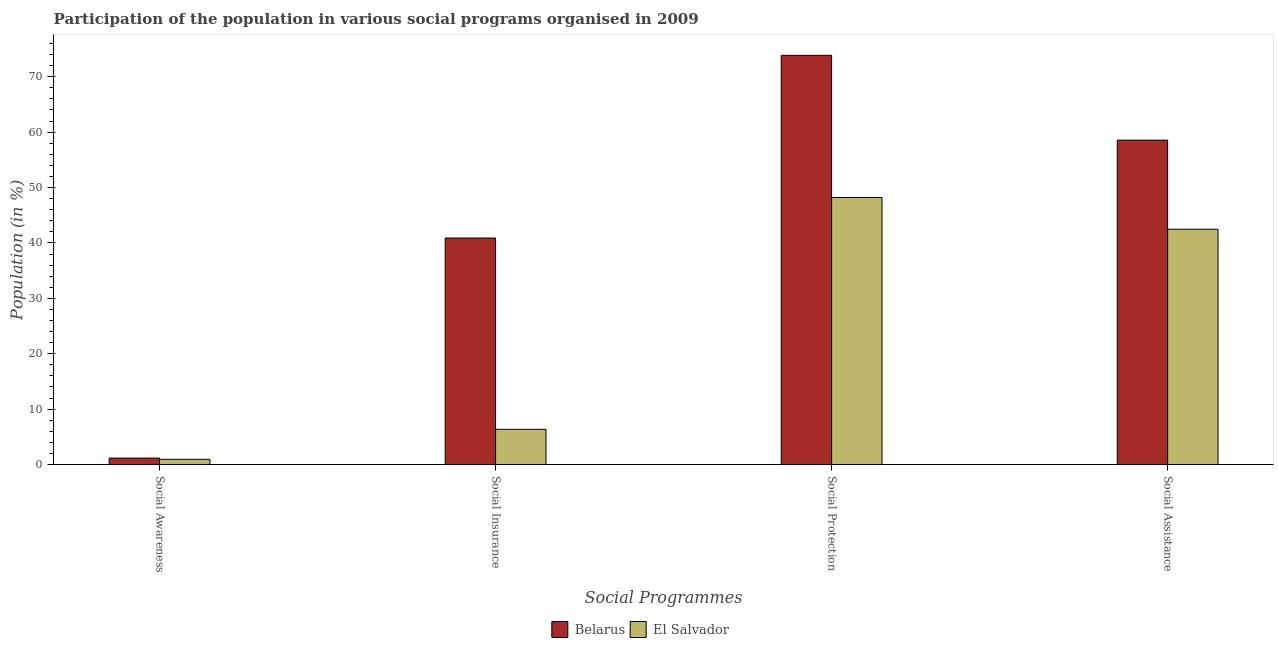Are the number of bars per tick equal to the number of legend labels?
Ensure brevity in your answer.  Yes. Are the number of bars on each tick of the X-axis equal?
Offer a very short reply. Yes. What is the label of the 4th group of bars from the left?
Give a very brief answer. Social Assistance. What is the participation of population in social assistance programs in El Salvador?
Your answer should be very brief. 42.48. Across all countries, what is the maximum participation of population in social assistance programs?
Ensure brevity in your answer.  58.55. Across all countries, what is the minimum participation of population in social awareness programs?
Your response must be concise. 0.95. In which country was the participation of population in social awareness programs maximum?
Offer a terse response. Belarus. In which country was the participation of population in social assistance programs minimum?
Keep it short and to the point. El Salvador. What is the total participation of population in social protection programs in the graph?
Ensure brevity in your answer.  122.06. What is the difference between the participation of population in social protection programs in Belarus and that in El Salvador?
Your response must be concise. 25.66. What is the difference between the participation of population in social awareness programs in Belarus and the participation of population in social insurance programs in El Salvador?
Give a very brief answer. -5.19. What is the average participation of population in social insurance programs per country?
Provide a short and direct response. 23.62. What is the difference between the participation of population in social insurance programs and participation of population in social protection programs in El Salvador?
Offer a very short reply. -41.84. What is the ratio of the participation of population in social awareness programs in Belarus to that in El Salvador?
Provide a short and direct response. 1.23. What is the difference between the highest and the second highest participation of population in social protection programs?
Make the answer very short. 25.66. What is the difference between the highest and the lowest participation of population in social assistance programs?
Keep it short and to the point. 16.07. In how many countries, is the participation of population in social assistance programs greater than the average participation of population in social assistance programs taken over all countries?
Offer a very short reply. 1. Is the sum of the participation of population in social assistance programs in Belarus and El Salvador greater than the maximum participation of population in social insurance programs across all countries?
Offer a terse response. Yes. Is it the case that in every country, the sum of the participation of population in social protection programs and participation of population in social assistance programs is greater than the sum of participation of population in social awareness programs and participation of population in social insurance programs?
Keep it short and to the point. Yes. What does the 2nd bar from the left in Social Insurance represents?
Keep it short and to the point. El Salvador. What does the 2nd bar from the right in Social Assistance represents?
Provide a succinct answer. Belarus. Is it the case that in every country, the sum of the participation of population in social awareness programs and participation of population in social insurance programs is greater than the participation of population in social protection programs?
Your answer should be very brief. No. Are all the bars in the graph horizontal?
Ensure brevity in your answer.  No. Are the values on the major ticks of Y-axis written in scientific E-notation?
Provide a short and direct response. No. Does the graph contain any zero values?
Make the answer very short. No. Where does the legend appear in the graph?
Offer a very short reply. Bottom center. How many legend labels are there?
Ensure brevity in your answer.  2. What is the title of the graph?
Give a very brief answer. Participation of the population in various social programs organised in 2009. What is the label or title of the X-axis?
Your answer should be compact. Social Programmes. What is the Population (in %) of Belarus in Social Awareness?
Your answer should be compact. 1.17. What is the Population (in %) in El Salvador in Social Awareness?
Provide a short and direct response. 0.95. What is the Population (in %) of Belarus in Social Insurance?
Offer a very short reply. 40.89. What is the Population (in %) in El Salvador in Social Insurance?
Offer a very short reply. 6.36. What is the Population (in %) in Belarus in Social Protection?
Offer a very short reply. 73.86. What is the Population (in %) in El Salvador in Social Protection?
Offer a very short reply. 48.2. What is the Population (in %) of Belarus in Social Assistance?
Your answer should be very brief. 58.55. What is the Population (in %) of El Salvador in Social Assistance?
Provide a short and direct response. 42.48. Across all Social Programmes, what is the maximum Population (in %) in Belarus?
Give a very brief answer. 73.86. Across all Social Programmes, what is the maximum Population (in %) in El Salvador?
Your response must be concise. 48.2. Across all Social Programmes, what is the minimum Population (in %) in Belarus?
Provide a succinct answer. 1.17. Across all Social Programmes, what is the minimum Population (in %) of El Salvador?
Offer a terse response. 0.95. What is the total Population (in %) of Belarus in the graph?
Your response must be concise. 174.46. What is the total Population (in %) in El Salvador in the graph?
Provide a succinct answer. 97.98. What is the difference between the Population (in %) in Belarus in Social Awareness and that in Social Insurance?
Provide a succinct answer. -39.72. What is the difference between the Population (in %) in El Salvador in Social Awareness and that in Social Insurance?
Provide a succinct answer. -5.41. What is the difference between the Population (in %) in Belarus in Social Awareness and that in Social Protection?
Ensure brevity in your answer.  -72.7. What is the difference between the Population (in %) in El Salvador in Social Awareness and that in Social Protection?
Keep it short and to the point. -47.26. What is the difference between the Population (in %) in Belarus in Social Awareness and that in Social Assistance?
Provide a short and direct response. -57.39. What is the difference between the Population (in %) in El Salvador in Social Awareness and that in Social Assistance?
Provide a succinct answer. -41.53. What is the difference between the Population (in %) in Belarus in Social Insurance and that in Social Protection?
Your answer should be compact. -32.98. What is the difference between the Population (in %) in El Salvador in Social Insurance and that in Social Protection?
Provide a succinct answer. -41.84. What is the difference between the Population (in %) in Belarus in Social Insurance and that in Social Assistance?
Provide a succinct answer. -17.67. What is the difference between the Population (in %) of El Salvador in Social Insurance and that in Social Assistance?
Your answer should be very brief. -36.12. What is the difference between the Population (in %) of Belarus in Social Protection and that in Social Assistance?
Give a very brief answer. 15.31. What is the difference between the Population (in %) of El Salvador in Social Protection and that in Social Assistance?
Keep it short and to the point. 5.72. What is the difference between the Population (in %) in Belarus in Social Awareness and the Population (in %) in El Salvador in Social Insurance?
Your answer should be compact. -5.19. What is the difference between the Population (in %) in Belarus in Social Awareness and the Population (in %) in El Salvador in Social Protection?
Your answer should be very brief. -47.04. What is the difference between the Population (in %) of Belarus in Social Awareness and the Population (in %) of El Salvador in Social Assistance?
Provide a short and direct response. -41.31. What is the difference between the Population (in %) in Belarus in Social Insurance and the Population (in %) in El Salvador in Social Protection?
Ensure brevity in your answer.  -7.32. What is the difference between the Population (in %) of Belarus in Social Insurance and the Population (in %) of El Salvador in Social Assistance?
Your answer should be compact. -1.59. What is the difference between the Population (in %) in Belarus in Social Protection and the Population (in %) in El Salvador in Social Assistance?
Your answer should be very brief. 31.38. What is the average Population (in %) in Belarus per Social Programmes?
Give a very brief answer. 43.62. What is the average Population (in %) in El Salvador per Social Programmes?
Your response must be concise. 24.5. What is the difference between the Population (in %) of Belarus and Population (in %) of El Salvador in Social Awareness?
Provide a short and direct response. 0.22. What is the difference between the Population (in %) in Belarus and Population (in %) in El Salvador in Social Insurance?
Your answer should be very brief. 34.53. What is the difference between the Population (in %) in Belarus and Population (in %) in El Salvador in Social Protection?
Your answer should be very brief. 25.66. What is the difference between the Population (in %) of Belarus and Population (in %) of El Salvador in Social Assistance?
Provide a short and direct response. 16.07. What is the ratio of the Population (in %) in Belarus in Social Awareness to that in Social Insurance?
Offer a very short reply. 0.03. What is the ratio of the Population (in %) of El Salvador in Social Awareness to that in Social Insurance?
Provide a succinct answer. 0.15. What is the ratio of the Population (in %) of Belarus in Social Awareness to that in Social Protection?
Provide a short and direct response. 0.02. What is the ratio of the Population (in %) in El Salvador in Social Awareness to that in Social Protection?
Your answer should be very brief. 0.02. What is the ratio of the Population (in %) of Belarus in Social Awareness to that in Social Assistance?
Your answer should be compact. 0.02. What is the ratio of the Population (in %) in El Salvador in Social Awareness to that in Social Assistance?
Your answer should be very brief. 0.02. What is the ratio of the Population (in %) of Belarus in Social Insurance to that in Social Protection?
Provide a short and direct response. 0.55. What is the ratio of the Population (in %) in El Salvador in Social Insurance to that in Social Protection?
Make the answer very short. 0.13. What is the ratio of the Population (in %) in Belarus in Social Insurance to that in Social Assistance?
Offer a terse response. 0.7. What is the ratio of the Population (in %) of El Salvador in Social Insurance to that in Social Assistance?
Offer a very short reply. 0.15. What is the ratio of the Population (in %) of Belarus in Social Protection to that in Social Assistance?
Your response must be concise. 1.26. What is the ratio of the Population (in %) in El Salvador in Social Protection to that in Social Assistance?
Your response must be concise. 1.13. What is the difference between the highest and the second highest Population (in %) in Belarus?
Offer a terse response. 15.31. What is the difference between the highest and the second highest Population (in %) in El Salvador?
Ensure brevity in your answer.  5.72. What is the difference between the highest and the lowest Population (in %) of Belarus?
Make the answer very short. 72.7. What is the difference between the highest and the lowest Population (in %) in El Salvador?
Offer a very short reply. 47.26. 